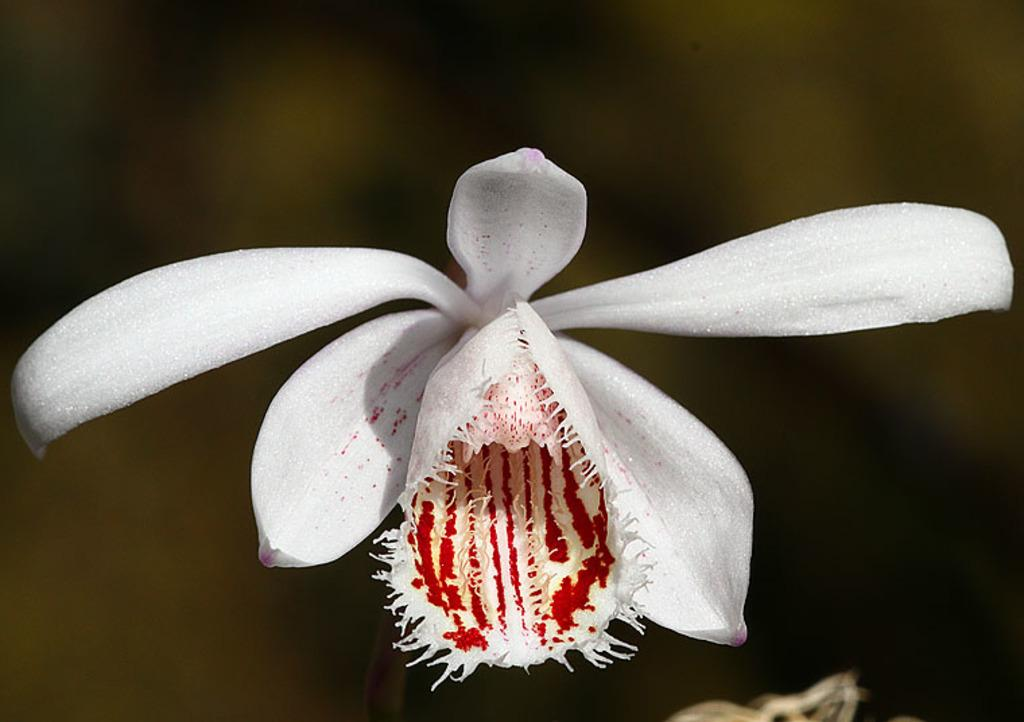What is the main subject of the image? There is a flower in the center of the image. Can you describe the flower in more detail? Unfortunately, the image does not provide enough detail to describe the flower further. Is there anything else in the image besides the flower? The facts provided do not mention any other objects or subjects in the image. How many snakes are wrapped around the flower in the image? There are no snakes present in the image; it features a flower in the center. What type of pie is being served alongside the flower in the image? There is no pie present in the image; it only features a flower. 